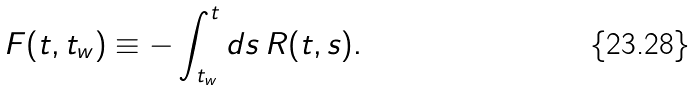Convert formula to latex. <formula><loc_0><loc_0><loc_500><loc_500>F ( t , t _ { w } ) \equiv - \int _ { t _ { w } } ^ { t } d s \, R ( t , s ) .</formula> 